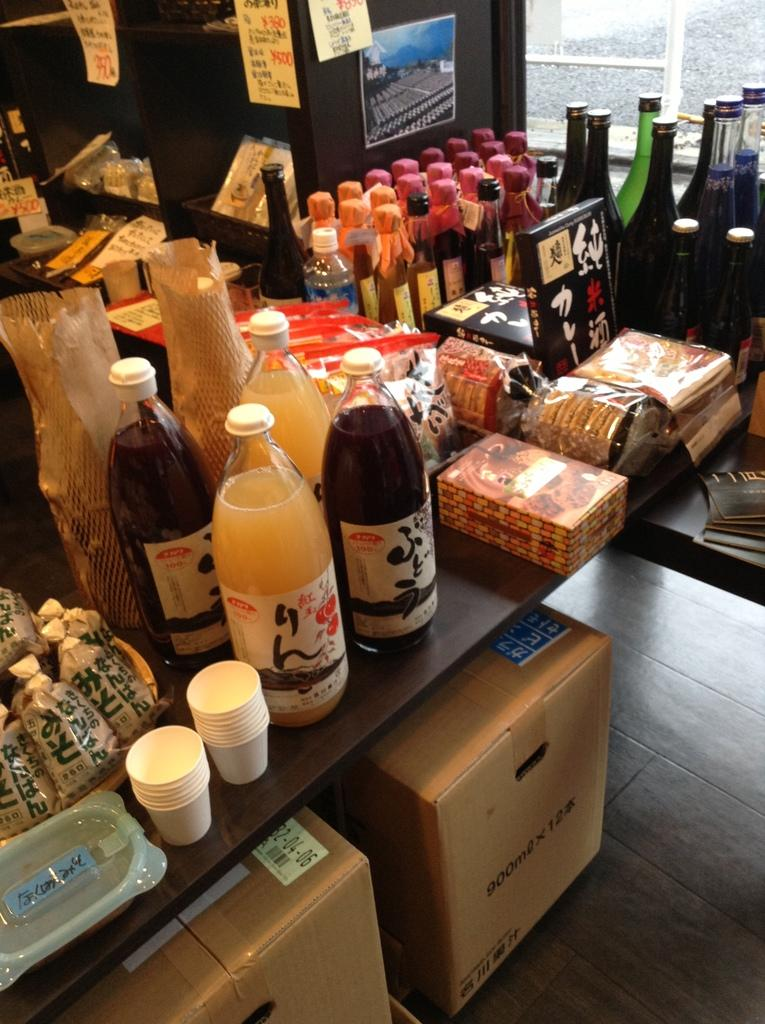What type of containers are visible in the image? There are bottles, boxes, and cups in the image. What else can be seen in the image besides containers? There are covers in the image. How are the boxes arranged in the image? There are 2 boxes stacked on top of each other in the image. What type of discussion is taking place between the snakes in the image? There are no snakes present in the image, so no discussion can be observed. 